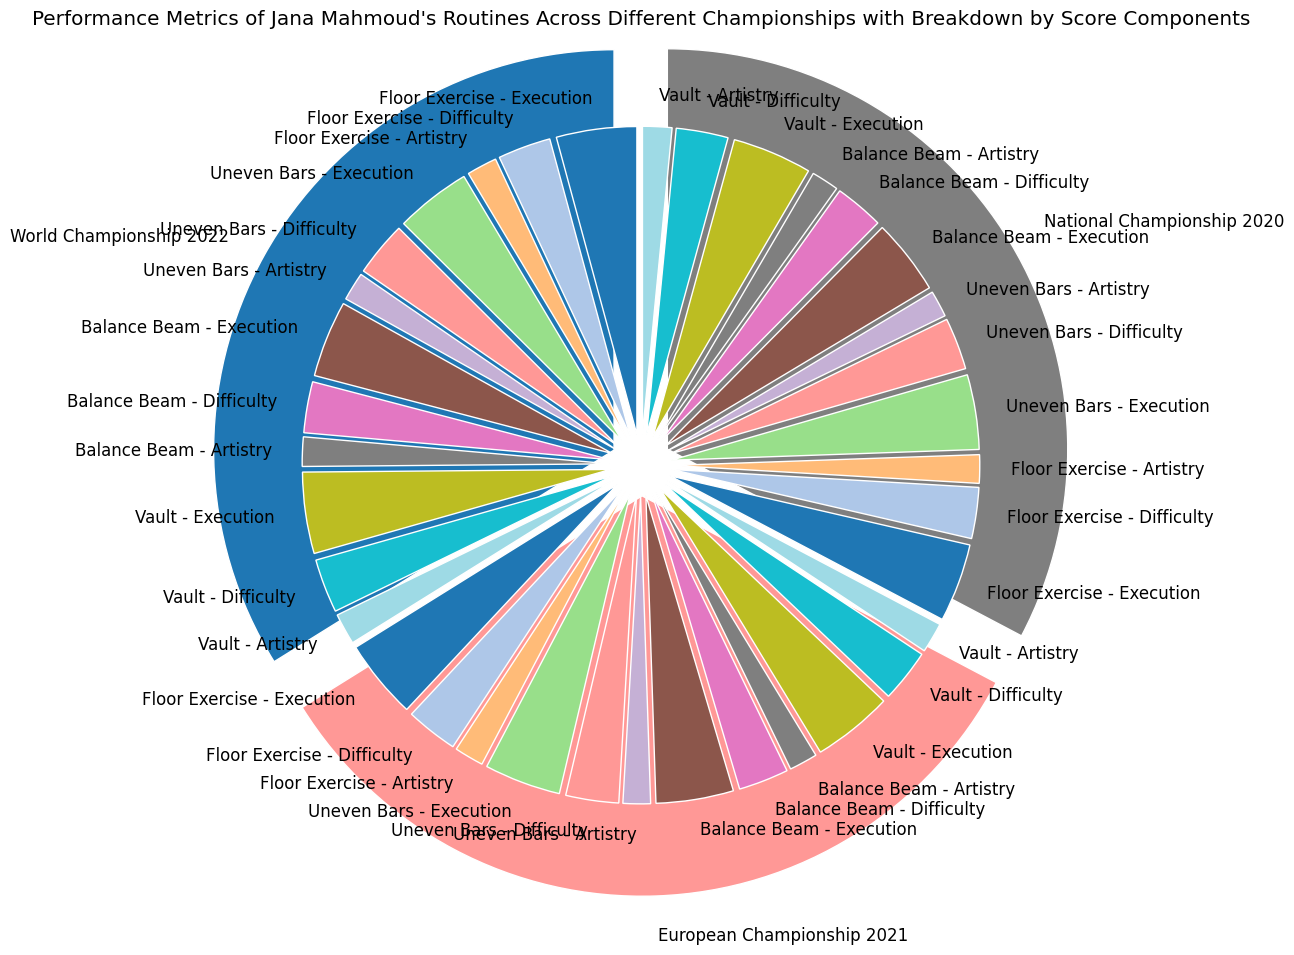What's the total score for Jana Mahmoud's Vault routines across all championships? To find the total score for Vault routines, sum the scores from the National Championship 2020, European Championship 2021, and World Championship 2022. These scores are 17.0, 17.3, and 17.6, respectively. So, 17.0 + 17.3 + 17.6 = 51.9.
Answer: 51.9 Which event had the highest Total Score in the World Championship 2022? Look at the Total Scores for each event in the World Championship 2022: Floor Exercise 17.3, Uneven Bars 16.8, Balance Beam 16.6, and Vault 17.6. The highest score is in Vault with 17.6.
Answer: Vault Compare the Execution Scores of Floor Exercise between the European Championship 2021 and the National Championship 2020: which one was higher? The Execution Score for Floor Exercise in the European Championship 2021 was 8.4, and in the National Championship 2020 it was 8.3. So, the score in the European Championship 2021 was higher.
Answer: European Championship 2021 Which championship had the highest aggregate Total Score across all events? Sum the Total Scores for each event in each championship: 
- World Championship 2022: 17.3 + 16.8 + 16.6 + 17.6 = 68.3
- European Championship 2021: 17.0 + 16.6 + 16.5 + 17.3 = 67.4
- National Championship 2020: 16.7 + 16.2 + 16.1 + 17.0 = 66.0. 
Hence, the World Championship 2022 had the highest aggregate Total Score.
Answer: World Championship 2022 What visual characteristic differentiates the outer pie chart segments? The outer pie chart segments are differentiated mainly by unique colors assigned to each championship and a slight explosion effect that separates them from one another.
Answer: Colors and explosion effect Which event in the National Championship 2020 had the lowest Total Score, and what was it? Compare the Total Scores for each event in the National Championship 2020: Floor Exercise 16.7, Uneven Bars 16.2, Balance Beam 16.1, and Vault 17.0. The lowest Total Score is 16.1 for Balance Beam.
Answer: Balance Beam, 16.1 What's the difference between the Difficulty Scores of Vault in the European Championship 2021 and the World Championship 2022? The Difficulty Score for Vault in the European Championship 2021 is 5.6 and in the World Championship 2022 it is 5.7. The difference is 5.7 - 5.6 = 0.1.
Answer: 0.1 How many different colors are used in the inner pie chart, and why is this important? The inner pie charts use a variety of colors to distinguish between the different score components (Execution, Difficulty, Artistry) and events. The importance lies in visually separating these components to make it easier to identify and compare the scores. Visually, there are as many colors as there are score labels.
Answer: Multiple colors, for differentiation 